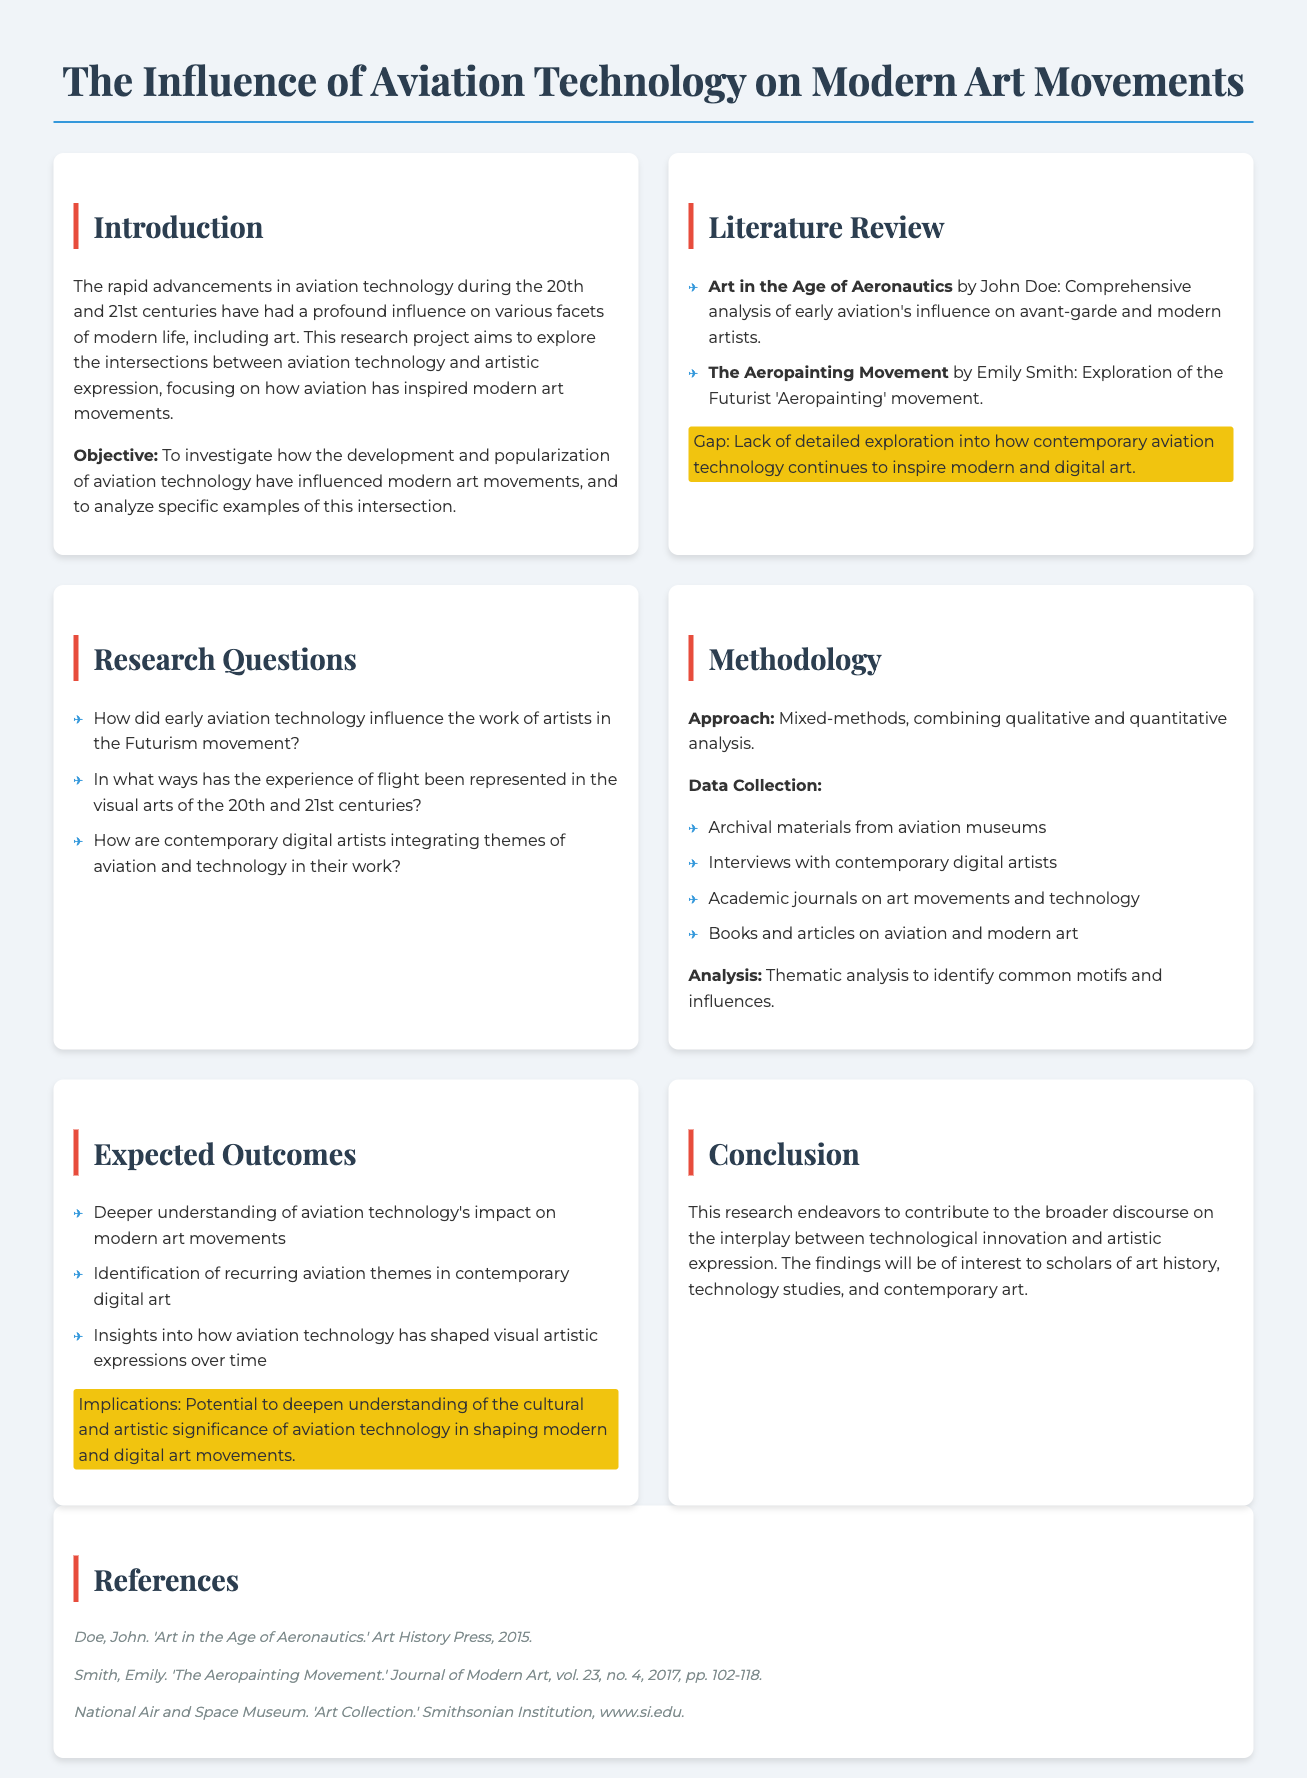What is the title of the research proposal? The title is found in the heading of the document.
Answer: The Influence of Aviation Technology on Modern Art Movements Who is the author of "Art in the Age of Aeronautics"? This information is listed in the literature review section of the document.
Answer: John Doe What method is used for data collection? This refers to the methodology section outlining the approach to gather information.
Answer: Archival materials from aviation museums What type of analysis will be conducted? This information is mentioned in the methodology section regarding how data will be examined.
Answer: Thematic analysis Which art movement is specifically mentioned in the research questions? The art movement is part of the inquiry about the influence of aviation technology.
Answer: Futurism What is one expected outcome of the research? The expected outcomes are listed in the corresponding section detailing anticipated findings.
Answer: Deeper understanding of aviation technology's impact on modern art movements What gap is identified in the literature review? The gap refers to the lack of specific exploration mentioned in the review section.
Answer: Lack of detailed exploration into how contemporary aviation technology continues to inspire modern and digital art What is the primary objective of the research proposal? The objective is stated clearly in the introduction of the document.
Answer: To investigate how the development and popularization of aviation technology have influenced modern art movements 